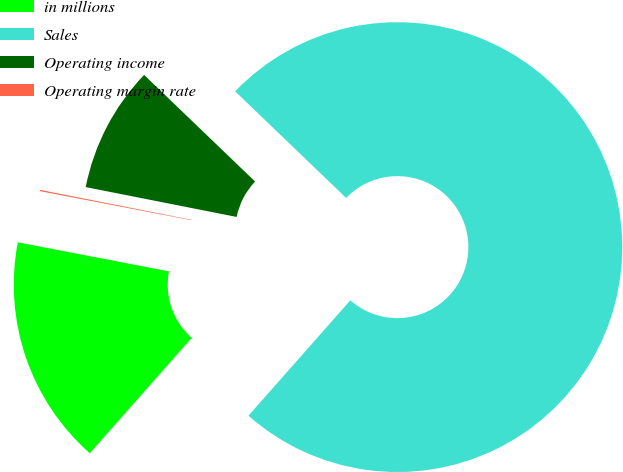Convert chart. <chart><loc_0><loc_0><loc_500><loc_500><pie_chart><fcel>in millions<fcel>Sales<fcel>Operating income<fcel>Operating margin rate<nl><fcel>16.5%<fcel>74.33%<fcel>9.07%<fcel>0.09%<nl></chart> 